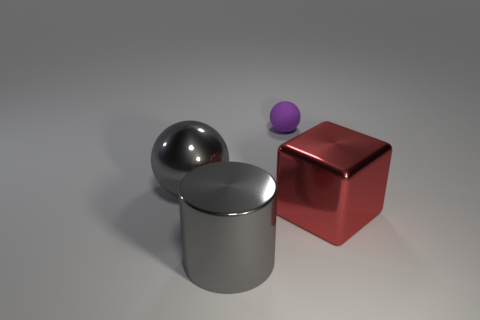Add 1 big metallic balls. How many objects exist? 5 Subtract all cylinders. How many objects are left? 3 Add 2 tiny purple matte spheres. How many tiny purple matte spheres are left? 3 Add 3 green metallic balls. How many green metallic balls exist? 3 Subtract 0 green cylinders. How many objects are left? 4 Subtract all large cubes. Subtract all tiny green metal cylinders. How many objects are left? 3 